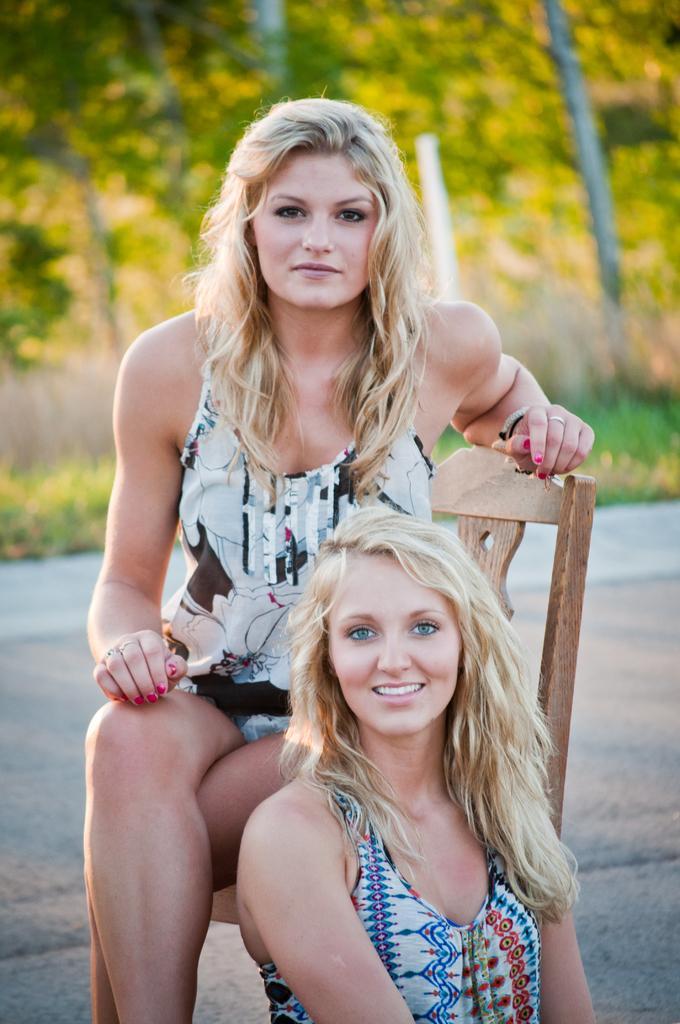Describe this image in one or two sentences. In this image, we can see a person wearing clothes and sitting on the chair. There is an another person at the bottom of the image. In the background, image is blurred. 